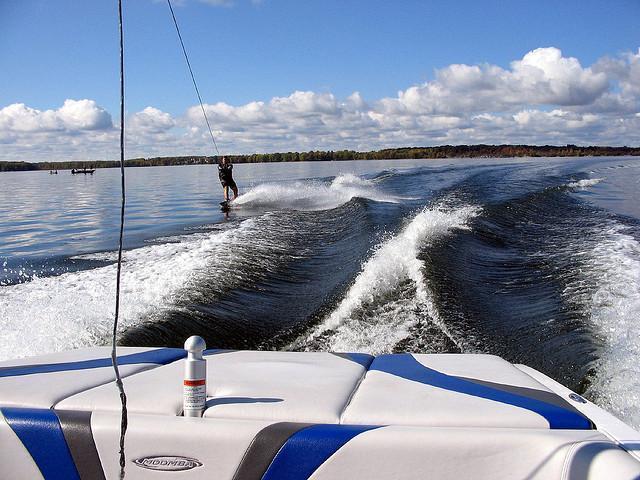How many of the train cars can you see someone sticking their head out of?
Give a very brief answer. 0. 